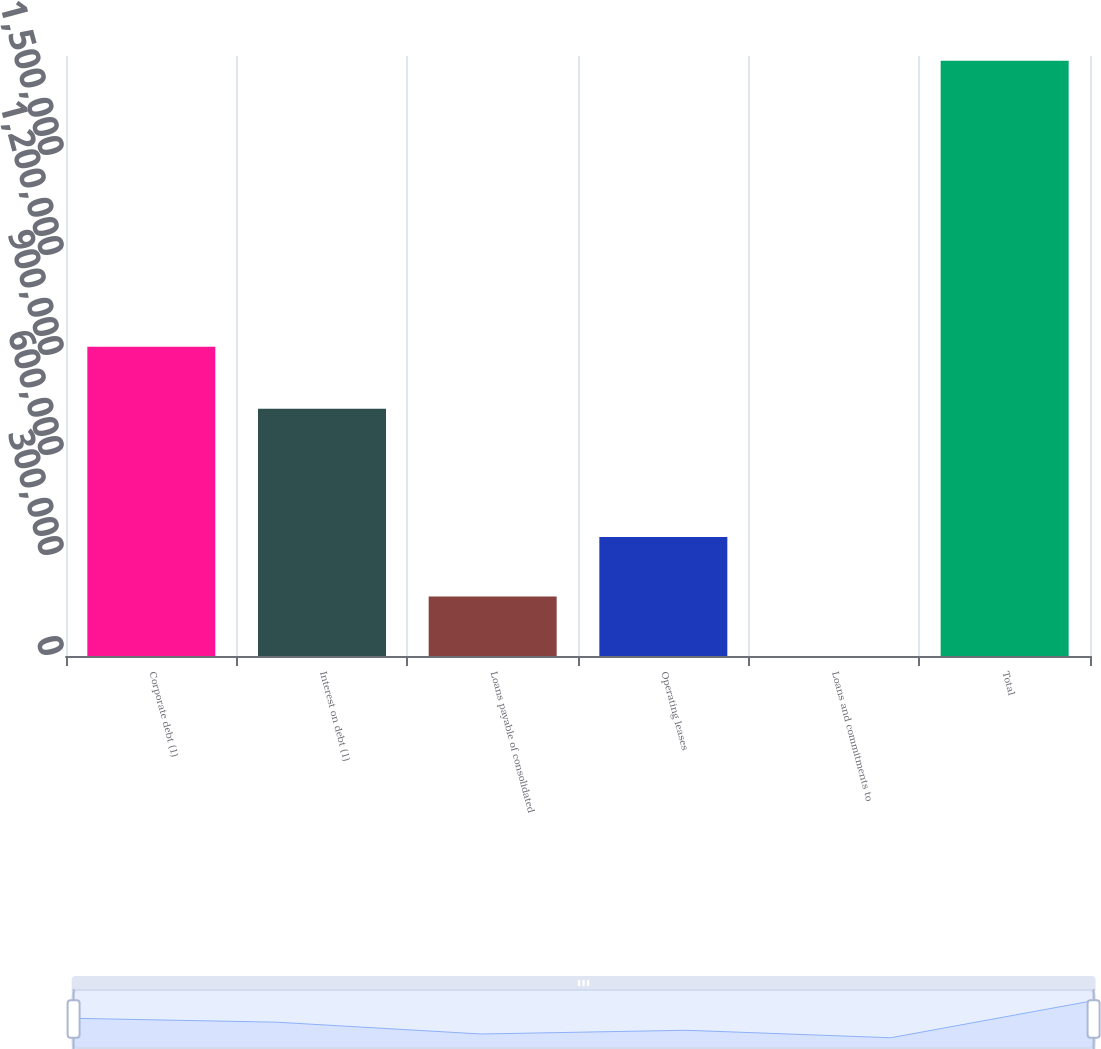Convert chart to OTSL. <chart><loc_0><loc_0><loc_500><loc_500><bar_chart><fcel>Corporate debt (1)<fcel>Interest on debt (1)<fcel>Loans payable of consolidated<fcel>Operating leases<fcel>Loans and commitments to<fcel>Total<nl><fcel>927826<fcel>741712<fcel>178807<fcel>357336<fcel>279<fcel>1.78556e+06<nl></chart> 